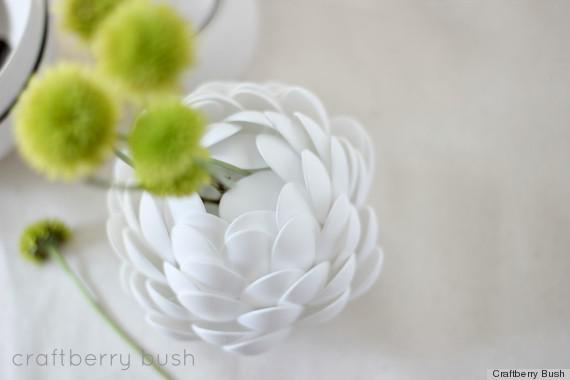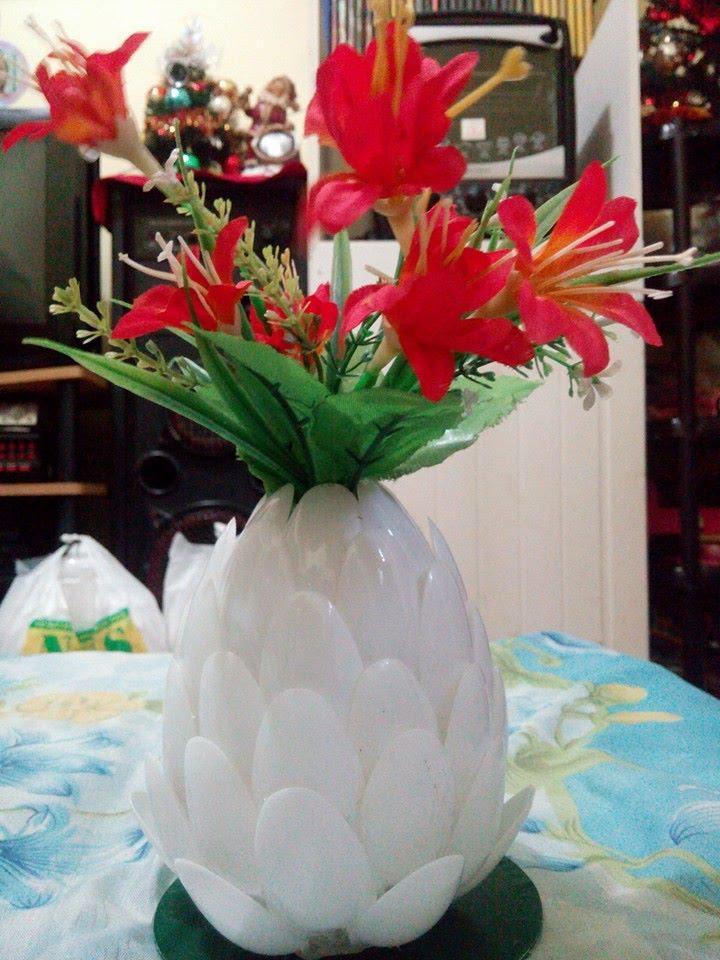The first image is the image on the left, the second image is the image on the right. Analyze the images presented: Is the assertion "Every container is either white or clear" valid? Answer yes or no. Yes. The first image is the image on the left, the second image is the image on the right. Given the left and right images, does the statement "Some of the vases are see-thru; you can see the stems through the vase walls." hold true? Answer yes or no. No. 